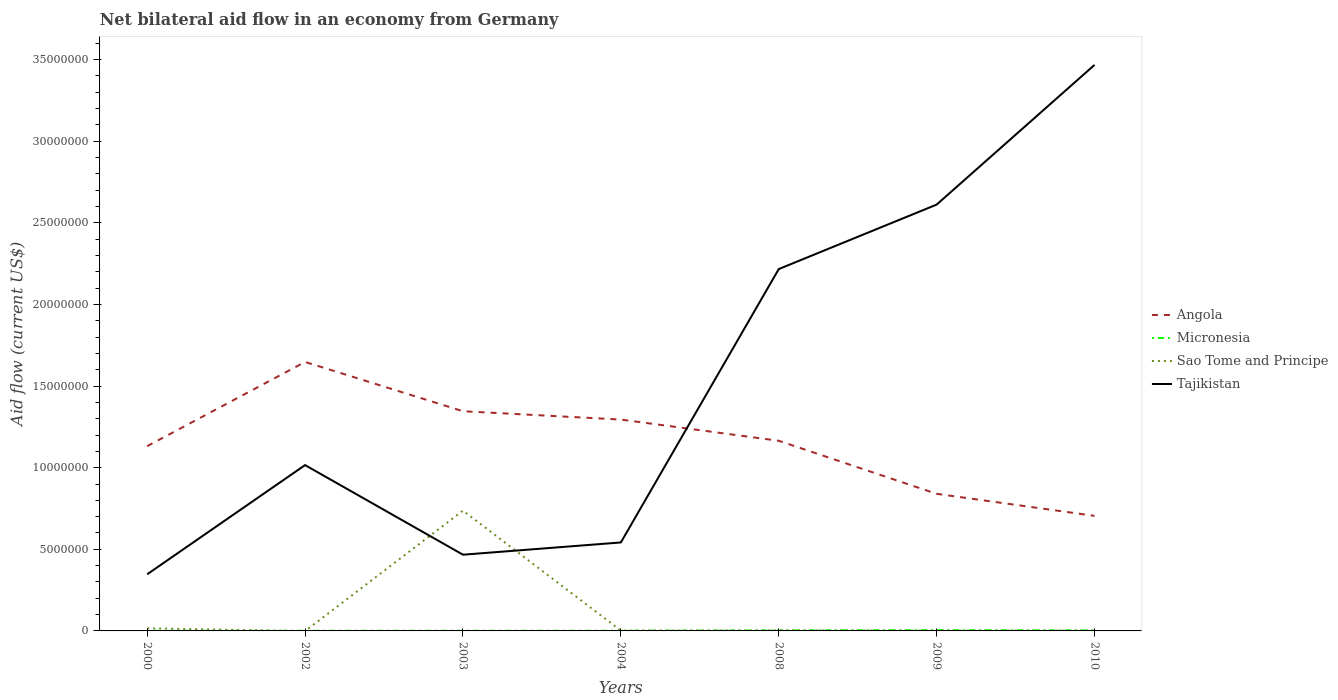Does the line corresponding to Angola intersect with the line corresponding to Tajikistan?
Your answer should be compact. Yes. What is the total net bilateral aid flow in Sao Tome and Principe in the graph?
Ensure brevity in your answer.  10000. What is the difference between the highest and the second highest net bilateral aid flow in Tajikistan?
Your response must be concise. 3.12e+07. What is the difference between two consecutive major ticks on the Y-axis?
Your answer should be very brief. 5.00e+06. Are the values on the major ticks of Y-axis written in scientific E-notation?
Your response must be concise. No. Does the graph contain grids?
Make the answer very short. No. Where does the legend appear in the graph?
Make the answer very short. Center right. What is the title of the graph?
Provide a succinct answer. Net bilateral aid flow in an economy from Germany. What is the Aid flow (current US$) in Angola in 2000?
Your response must be concise. 1.13e+07. What is the Aid flow (current US$) in Micronesia in 2000?
Give a very brief answer. 10000. What is the Aid flow (current US$) in Sao Tome and Principe in 2000?
Offer a terse response. 1.60e+05. What is the Aid flow (current US$) of Tajikistan in 2000?
Provide a short and direct response. 3.47e+06. What is the Aid flow (current US$) of Angola in 2002?
Ensure brevity in your answer.  1.65e+07. What is the Aid flow (current US$) in Micronesia in 2002?
Your answer should be very brief. 10000. What is the Aid flow (current US$) in Sao Tome and Principe in 2002?
Ensure brevity in your answer.  0. What is the Aid flow (current US$) in Tajikistan in 2002?
Your response must be concise. 1.02e+07. What is the Aid flow (current US$) of Angola in 2003?
Keep it short and to the point. 1.35e+07. What is the Aid flow (current US$) in Micronesia in 2003?
Your response must be concise. 10000. What is the Aid flow (current US$) of Sao Tome and Principe in 2003?
Give a very brief answer. 7.37e+06. What is the Aid flow (current US$) in Tajikistan in 2003?
Make the answer very short. 4.67e+06. What is the Aid flow (current US$) in Angola in 2004?
Your answer should be compact. 1.30e+07. What is the Aid flow (current US$) in Micronesia in 2004?
Your answer should be very brief. 10000. What is the Aid flow (current US$) of Tajikistan in 2004?
Your response must be concise. 5.42e+06. What is the Aid flow (current US$) of Angola in 2008?
Provide a succinct answer. 1.16e+07. What is the Aid flow (current US$) in Micronesia in 2008?
Provide a succinct answer. 3.00e+04. What is the Aid flow (current US$) of Sao Tome and Principe in 2008?
Give a very brief answer. 3.00e+04. What is the Aid flow (current US$) in Tajikistan in 2008?
Make the answer very short. 2.22e+07. What is the Aid flow (current US$) in Angola in 2009?
Ensure brevity in your answer.  8.40e+06. What is the Aid flow (current US$) in Tajikistan in 2009?
Your response must be concise. 2.61e+07. What is the Aid flow (current US$) in Angola in 2010?
Offer a very short reply. 7.05e+06. What is the Aid flow (current US$) in Micronesia in 2010?
Your answer should be very brief. 3.00e+04. What is the Aid flow (current US$) in Tajikistan in 2010?
Ensure brevity in your answer.  3.47e+07. Across all years, what is the maximum Aid flow (current US$) of Angola?
Offer a terse response. 1.65e+07. Across all years, what is the maximum Aid flow (current US$) in Micronesia?
Your answer should be very brief. 5.00e+04. Across all years, what is the maximum Aid flow (current US$) of Sao Tome and Principe?
Provide a short and direct response. 7.37e+06. Across all years, what is the maximum Aid flow (current US$) in Tajikistan?
Provide a succinct answer. 3.47e+07. Across all years, what is the minimum Aid flow (current US$) in Angola?
Provide a short and direct response. 7.05e+06. Across all years, what is the minimum Aid flow (current US$) in Sao Tome and Principe?
Keep it short and to the point. 0. Across all years, what is the minimum Aid flow (current US$) in Tajikistan?
Make the answer very short. 3.47e+06. What is the total Aid flow (current US$) in Angola in the graph?
Provide a succinct answer. 8.13e+07. What is the total Aid flow (current US$) in Micronesia in the graph?
Provide a succinct answer. 1.50e+05. What is the total Aid flow (current US$) in Sao Tome and Principe in the graph?
Ensure brevity in your answer.  7.61e+06. What is the total Aid flow (current US$) in Tajikistan in the graph?
Offer a very short reply. 1.07e+08. What is the difference between the Aid flow (current US$) in Angola in 2000 and that in 2002?
Your response must be concise. -5.16e+06. What is the difference between the Aid flow (current US$) of Micronesia in 2000 and that in 2002?
Provide a succinct answer. 0. What is the difference between the Aid flow (current US$) in Tajikistan in 2000 and that in 2002?
Provide a short and direct response. -6.69e+06. What is the difference between the Aid flow (current US$) in Angola in 2000 and that in 2003?
Make the answer very short. -2.14e+06. What is the difference between the Aid flow (current US$) of Sao Tome and Principe in 2000 and that in 2003?
Keep it short and to the point. -7.21e+06. What is the difference between the Aid flow (current US$) in Tajikistan in 2000 and that in 2003?
Ensure brevity in your answer.  -1.20e+06. What is the difference between the Aid flow (current US$) of Angola in 2000 and that in 2004?
Your response must be concise. -1.63e+06. What is the difference between the Aid flow (current US$) in Tajikistan in 2000 and that in 2004?
Provide a succinct answer. -1.95e+06. What is the difference between the Aid flow (current US$) in Angola in 2000 and that in 2008?
Your response must be concise. -3.30e+05. What is the difference between the Aid flow (current US$) of Tajikistan in 2000 and that in 2008?
Your answer should be compact. -1.87e+07. What is the difference between the Aid flow (current US$) in Angola in 2000 and that in 2009?
Offer a terse response. 2.92e+06. What is the difference between the Aid flow (current US$) of Micronesia in 2000 and that in 2009?
Provide a short and direct response. -4.00e+04. What is the difference between the Aid flow (current US$) of Tajikistan in 2000 and that in 2009?
Make the answer very short. -2.26e+07. What is the difference between the Aid flow (current US$) in Angola in 2000 and that in 2010?
Keep it short and to the point. 4.27e+06. What is the difference between the Aid flow (current US$) in Micronesia in 2000 and that in 2010?
Keep it short and to the point. -2.00e+04. What is the difference between the Aid flow (current US$) of Tajikistan in 2000 and that in 2010?
Offer a very short reply. -3.12e+07. What is the difference between the Aid flow (current US$) of Angola in 2002 and that in 2003?
Make the answer very short. 3.02e+06. What is the difference between the Aid flow (current US$) in Micronesia in 2002 and that in 2003?
Provide a succinct answer. 0. What is the difference between the Aid flow (current US$) of Tajikistan in 2002 and that in 2003?
Make the answer very short. 5.49e+06. What is the difference between the Aid flow (current US$) in Angola in 2002 and that in 2004?
Your answer should be compact. 3.53e+06. What is the difference between the Aid flow (current US$) in Micronesia in 2002 and that in 2004?
Provide a succinct answer. 0. What is the difference between the Aid flow (current US$) in Tajikistan in 2002 and that in 2004?
Offer a terse response. 4.74e+06. What is the difference between the Aid flow (current US$) of Angola in 2002 and that in 2008?
Your response must be concise. 4.83e+06. What is the difference between the Aid flow (current US$) of Micronesia in 2002 and that in 2008?
Make the answer very short. -2.00e+04. What is the difference between the Aid flow (current US$) of Tajikistan in 2002 and that in 2008?
Make the answer very short. -1.20e+07. What is the difference between the Aid flow (current US$) in Angola in 2002 and that in 2009?
Offer a very short reply. 8.08e+06. What is the difference between the Aid flow (current US$) in Micronesia in 2002 and that in 2009?
Provide a short and direct response. -4.00e+04. What is the difference between the Aid flow (current US$) of Tajikistan in 2002 and that in 2009?
Offer a very short reply. -1.60e+07. What is the difference between the Aid flow (current US$) in Angola in 2002 and that in 2010?
Provide a short and direct response. 9.43e+06. What is the difference between the Aid flow (current US$) in Tajikistan in 2002 and that in 2010?
Your answer should be compact. -2.45e+07. What is the difference between the Aid flow (current US$) of Angola in 2003 and that in 2004?
Offer a very short reply. 5.10e+05. What is the difference between the Aid flow (current US$) of Sao Tome and Principe in 2003 and that in 2004?
Offer a terse response. 7.35e+06. What is the difference between the Aid flow (current US$) of Tajikistan in 2003 and that in 2004?
Ensure brevity in your answer.  -7.50e+05. What is the difference between the Aid flow (current US$) in Angola in 2003 and that in 2008?
Make the answer very short. 1.81e+06. What is the difference between the Aid flow (current US$) of Sao Tome and Principe in 2003 and that in 2008?
Make the answer very short. 7.34e+06. What is the difference between the Aid flow (current US$) in Tajikistan in 2003 and that in 2008?
Your answer should be compact. -1.75e+07. What is the difference between the Aid flow (current US$) in Angola in 2003 and that in 2009?
Offer a very short reply. 5.06e+06. What is the difference between the Aid flow (current US$) of Micronesia in 2003 and that in 2009?
Provide a short and direct response. -4.00e+04. What is the difference between the Aid flow (current US$) of Sao Tome and Principe in 2003 and that in 2009?
Offer a terse response. 7.36e+06. What is the difference between the Aid flow (current US$) in Tajikistan in 2003 and that in 2009?
Offer a terse response. -2.14e+07. What is the difference between the Aid flow (current US$) in Angola in 2003 and that in 2010?
Your answer should be very brief. 6.41e+06. What is the difference between the Aid flow (current US$) in Micronesia in 2003 and that in 2010?
Give a very brief answer. -2.00e+04. What is the difference between the Aid flow (current US$) of Sao Tome and Principe in 2003 and that in 2010?
Make the answer very short. 7.35e+06. What is the difference between the Aid flow (current US$) of Tajikistan in 2003 and that in 2010?
Give a very brief answer. -3.00e+07. What is the difference between the Aid flow (current US$) in Angola in 2004 and that in 2008?
Your answer should be very brief. 1.30e+06. What is the difference between the Aid flow (current US$) in Tajikistan in 2004 and that in 2008?
Give a very brief answer. -1.68e+07. What is the difference between the Aid flow (current US$) in Angola in 2004 and that in 2009?
Ensure brevity in your answer.  4.55e+06. What is the difference between the Aid flow (current US$) in Tajikistan in 2004 and that in 2009?
Offer a terse response. -2.07e+07. What is the difference between the Aid flow (current US$) in Angola in 2004 and that in 2010?
Ensure brevity in your answer.  5.90e+06. What is the difference between the Aid flow (current US$) in Micronesia in 2004 and that in 2010?
Offer a terse response. -2.00e+04. What is the difference between the Aid flow (current US$) of Tajikistan in 2004 and that in 2010?
Make the answer very short. -2.93e+07. What is the difference between the Aid flow (current US$) of Angola in 2008 and that in 2009?
Your answer should be compact. 3.25e+06. What is the difference between the Aid flow (current US$) in Sao Tome and Principe in 2008 and that in 2009?
Your answer should be compact. 2.00e+04. What is the difference between the Aid flow (current US$) of Tajikistan in 2008 and that in 2009?
Provide a succinct answer. -3.95e+06. What is the difference between the Aid flow (current US$) in Angola in 2008 and that in 2010?
Your answer should be very brief. 4.60e+06. What is the difference between the Aid flow (current US$) of Micronesia in 2008 and that in 2010?
Your response must be concise. 0. What is the difference between the Aid flow (current US$) of Sao Tome and Principe in 2008 and that in 2010?
Provide a short and direct response. 10000. What is the difference between the Aid flow (current US$) of Tajikistan in 2008 and that in 2010?
Keep it short and to the point. -1.25e+07. What is the difference between the Aid flow (current US$) of Angola in 2009 and that in 2010?
Give a very brief answer. 1.35e+06. What is the difference between the Aid flow (current US$) in Tajikistan in 2009 and that in 2010?
Provide a succinct answer. -8.56e+06. What is the difference between the Aid flow (current US$) of Angola in 2000 and the Aid flow (current US$) of Micronesia in 2002?
Offer a very short reply. 1.13e+07. What is the difference between the Aid flow (current US$) in Angola in 2000 and the Aid flow (current US$) in Tajikistan in 2002?
Ensure brevity in your answer.  1.16e+06. What is the difference between the Aid flow (current US$) in Micronesia in 2000 and the Aid flow (current US$) in Tajikistan in 2002?
Provide a short and direct response. -1.02e+07. What is the difference between the Aid flow (current US$) of Sao Tome and Principe in 2000 and the Aid flow (current US$) of Tajikistan in 2002?
Make the answer very short. -1.00e+07. What is the difference between the Aid flow (current US$) in Angola in 2000 and the Aid flow (current US$) in Micronesia in 2003?
Keep it short and to the point. 1.13e+07. What is the difference between the Aid flow (current US$) in Angola in 2000 and the Aid flow (current US$) in Sao Tome and Principe in 2003?
Provide a short and direct response. 3.95e+06. What is the difference between the Aid flow (current US$) of Angola in 2000 and the Aid flow (current US$) of Tajikistan in 2003?
Your response must be concise. 6.65e+06. What is the difference between the Aid flow (current US$) of Micronesia in 2000 and the Aid flow (current US$) of Sao Tome and Principe in 2003?
Ensure brevity in your answer.  -7.36e+06. What is the difference between the Aid flow (current US$) of Micronesia in 2000 and the Aid flow (current US$) of Tajikistan in 2003?
Make the answer very short. -4.66e+06. What is the difference between the Aid flow (current US$) of Sao Tome and Principe in 2000 and the Aid flow (current US$) of Tajikistan in 2003?
Your answer should be compact. -4.51e+06. What is the difference between the Aid flow (current US$) of Angola in 2000 and the Aid flow (current US$) of Micronesia in 2004?
Give a very brief answer. 1.13e+07. What is the difference between the Aid flow (current US$) of Angola in 2000 and the Aid flow (current US$) of Sao Tome and Principe in 2004?
Your answer should be very brief. 1.13e+07. What is the difference between the Aid flow (current US$) in Angola in 2000 and the Aid flow (current US$) in Tajikistan in 2004?
Your response must be concise. 5.90e+06. What is the difference between the Aid flow (current US$) in Micronesia in 2000 and the Aid flow (current US$) in Tajikistan in 2004?
Your answer should be very brief. -5.41e+06. What is the difference between the Aid flow (current US$) of Sao Tome and Principe in 2000 and the Aid flow (current US$) of Tajikistan in 2004?
Keep it short and to the point. -5.26e+06. What is the difference between the Aid flow (current US$) of Angola in 2000 and the Aid flow (current US$) of Micronesia in 2008?
Ensure brevity in your answer.  1.13e+07. What is the difference between the Aid flow (current US$) in Angola in 2000 and the Aid flow (current US$) in Sao Tome and Principe in 2008?
Ensure brevity in your answer.  1.13e+07. What is the difference between the Aid flow (current US$) of Angola in 2000 and the Aid flow (current US$) of Tajikistan in 2008?
Your answer should be compact. -1.08e+07. What is the difference between the Aid flow (current US$) in Micronesia in 2000 and the Aid flow (current US$) in Tajikistan in 2008?
Make the answer very short. -2.22e+07. What is the difference between the Aid flow (current US$) of Sao Tome and Principe in 2000 and the Aid flow (current US$) of Tajikistan in 2008?
Your answer should be very brief. -2.20e+07. What is the difference between the Aid flow (current US$) of Angola in 2000 and the Aid flow (current US$) of Micronesia in 2009?
Make the answer very short. 1.13e+07. What is the difference between the Aid flow (current US$) in Angola in 2000 and the Aid flow (current US$) in Sao Tome and Principe in 2009?
Offer a very short reply. 1.13e+07. What is the difference between the Aid flow (current US$) of Angola in 2000 and the Aid flow (current US$) of Tajikistan in 2009?
Your answer should be very brief. -1.48e+07. What is the difference between the Aid flow (current US$) in Micronesia in 2000 and the Aid flow (current US$) in Sao Tome and Principe in 2009?
Your answer should be compact. 0. What is the difference between the Aid flow (current US$) in Micronesia in 2000 and the Aid flow (current US$) in Tajikistan in 2009?
Your answer should be very brief. -2.61e+07. What is the difference between the Aid flow (current US$) in Sao Tome and Principe in 2000 and the Aid flow (current US$) in Tajikistan in 2009?
Ensure brevity in your answer.  -2.60e+07. What is the difference between the Aid flow (current US$) of Angola in 2000 and the Aid flow (current US$) of Micronesia in 2010?
Your answer should be compact. 1.13e+07. What is the difference between the Aid flow (current US$) of Angola in 2000 and the Aid flow (current US$) of Sao Tome and Principe in 2010?
Give a very brief answer. 1.13e+07. What is the difference between the Aid flow (current US$) of Angola in 2000 and the Aid flow (current US$) of Tajikistan in 2010?
Give a very brief answer. -2.34e+07. What is the difference between the Aid flow (current US$) of Micronesia in 2000 and the Aid flow (current US$) of Tajikistan in 2010?
Your response must be concise. -3.47e+07. What is the difference between the Aid flow (current US$) in Sao Tome and Principe in 2000 and the Aid flow (current US$) in Tajikistan in 2010?
Your answer should be very brief. -3.45e+07. What is the difference between the Aid flow (current US$) in Angola in 2002 and the Aid flow (current US$) in Micronesia in 2003?
Provide a succinct answer. 1.65e+07. What is the difference between the Aid flow (current US$) of Angola in 2002 and the Aid flow (current US$) of Sao Tome and Principe in 2003?
Give a very brief answer. 9.11e+06. What is the difference between the Aid flow (current US$) in Angola in 2002 and the Aid flow (current US$) in Tajikistan in 2003?
Keep it short and to the point. 1.18e+07. What is the difference between the Aid flow (current US$) of Micronesia in 2002 and the Aid flow (current US$) of Sao Tome and Principe in 2003?
Keep it short and to the point. -7.36e+06. What is the difference between the Aid flow (current US$) of Micronesia in 2002 and the Aid flow (current US$) of Tajikistan in 2003?
Your response must be concise. -4.66e+06. What is the difference between the Aid flow (current US$) of Angola in 2002 and the Aid flow (current US$) of Micronesia in 2004?
Offer a terse response. 1.65e+07. What is the difference between the Aid flow (current US$) in Angola in 2002 and the Aid flow (current US$) in Sao Tome and Principe in 2004?
Your response must be concise. 1.65e+07. What is the difference between the Aid flow (current US$) of Angola in 2002 and the Aid flow (current US$) of Tajikistan in 2004?
Offer a very short reply. 1.11e+07. What is the difference between the Aid flow (current US$) in Micronesia in 2002 and the Aid flow (current US$) in Tajikistan in 2004?
Your answer should be compact. -5.41e+06. What is the difference between the Aid flow (current US$) of Angola in 2002 and the Aid flow (current US$) of Micronesia in 2008?
Ensure brevity in your answer.  1.64e+07. What is the difference between the Aid flow (current US$) in Angola in 2002 and the Aid flow (current US$) in Sao Tome and Principe in 2008?
Provide a short and direct response. 1.64e+07. What is the difference between the Aid flow (current US$) of Angola in 2002 and the Aid flow (current US$) of Tajikistan in 2008?
Provide a succinct answer. -5.69e+06. What is the difference between the Aid flow (current US$) of Micronesia in 2002 and the Aid flow (current US$) of Sao Tome and Principe in 2008?
Keep it short and to the point. -2.00e+04. What is the difference between the Aid flow (current US$) of Micronesia in 2002 and the Aid flow (current US$) of Tajikistan in 2008?
Ensure brevity in your answer.  -2.22e+07. What is the difference between the Aid flow (current US$) of Angola in 2002 and the Aid flow (current US$) of Micronesia in 2009?
Offer a terse response. 1.64e+07. What is the difference between the Aid flow (current US$) in Angola in 2002 and the Aid flow (current US$) in Sao Tome and Principe in 2009?
Ensure brevity in your answer.  1.65e+07. What is the difference between the Aid flow (current US$) of Angola in 2002 and the Aid flow (current US$) of Tajikistan in 2009?
Your answer should be very brief. -9.64e+06. What is the difference between the Aid flow (current US$) in Micronesia in 2002 and the Aid flow (current US$) in Tajikistan in 2009?
Keep it short and to the point. -2.61e+07. What is the difference between the Aid flow (current US$) in Angola in 2002 and the Aid flow (current US$) in Micronesia in 2010?
Make the answer very short. 1.64e+07. What is the difference between the Aid flow (current US$) of Angola in 2002 and the Aid flow (current US$) of Sao Tome and Principe in 2010?
Make the answer very short. 1.65e+07. What is the difference between the Aid flow (current US$) of Angola in 2002 and the Aid flow (current US$) of Tajikistan in 2010?
Give a very brief answer. -1.82e+07. What is the difference between the Aid flow (current US$) of Micronesia in 2002 and the Aid flow (current US$) of Sao Tome and Principe in 2010?
Keep it short and to the point. -10000. What is the difference between the Aid flow (current US$) in Micronesia in 2002 and the Aid flow (current US$) in Tajikistan in 2010?
Give a very brief answer. -3.47e+07. What is the difference between the Aid flow (current US$) in Angola in 2003 and the Aid flow (current US$) in Micronesia in 2004?
Give a very brief answer. 1.34e+07. What is the difference between the Aid flow (current US$) in Angola in 2003 and the Aid flow (current US$) in Sao Tome and Principe in 2004?
Give a very brief answer. 1.34e+07. What is the difference between the Aid flow (current US$) in Angola in 2003 and the Aid flow (current US$) in Tajikistan in 2004?
Provide a succinct answer. 8.04e+06. What is the difference between the Aid flow (current US$) of Micronesia in 2003 and the Aid flow (current US$) of Sao Tome and Principe in 2004?
Provide a succinct answer. -10000. What is the difference between the Aid flow (current US$) in Micronesia in 2003 and the Aid flow (current US$) in Tajikistan in 2004?
Your answer should be very brief. -5.41e+06. What is the difference between the Aid flow (current US$) of Sao Tome and Principe in 2003 and the Aid flow (current US$) of Tajikistan in 2004?
Offer a terse response. 1.95e+06. What is the difference between the Aid flow (current US$) in Angola in 2003 and the Aid flow (current US$) in Micronesia in 2008?
Provide a succinct answer. 1.34e+07. What is the difference between the Aid flow (current US$) of Angola in 2003 and the Aid flow (current US$) of Sao Tome and Principe in 2008?
Provide a succinct answer. 1.34e+07. What is the difference between the Aid flow (current US$) in Angola in 2003 and the Aid flow (current US$) in Tajikistan in 2008?
Your answer should be compact. -8.71e+06. What is the difference between the Aid flow (current US$) of Micronesia in 2003 and the Aid flow (current US$) of Tajikistan in 2008?
Your response must be concise. -2.22e+07. What is the difference between the Aid flow (current US$) in Sao Tome and Principe in 2003 and the Aid flow (current US$) in Tajikistan in 2008?
Give a very brief answer. -1.48e+07. What is the difference between the Aid flow (current US$) in Angola in 2003 and the Aid flow (current US$) in Micronesia in 2009?
Give a very brief answer. 1.34e+07. What is the difference between the Aid flow (current US$) in Angola in 2003 and the Aid flow (current US$) in Sao Tome and Principe in 2009?
Your answer should be very brief. 1.34e+07. What is the difference between the Aid flow (current US$) of Angola in 2003 and the Aid flow (current US$) of Tajikistan in 2009?
Provide a succinct answer. -1.27e+07. What is the difference between the Aid flow (current US$) in Micronesia in 2003 and the Aid flow (current US$) in Tajikistan in 2009?
Your answer should be very brief. -2.61e+07. What is the difference between the Aid flow (current US$) in Sao Tome and Principe in 2003 and the Aid flow (current US$) in Tajikistan in 2009?
Make the answer very short. -1.88e+07. What is the difference between the Aid flow (current US$) in Angola in 2003 and the Aid flow (current US$) in Micronesia in 2010?
Your answer should be compact. 1.34e+07. What is the difference between the Aid flow (current US$) in Angola in 2003 and the Aid flow (current US$) in Sao Tome and Principe in 2010?
Your answer should be very brief. 1.34e+07. What is the difference between the Aid flow (current US$) in Angola in 2003 and the Aid flow (current US$) in Tajikistan in 2010?
Make the answer very short. -2.12e+07. What is the difference between the Aid flow (current US$) of Micronesia in 2003 and the Aid flow (current US$) of Sao Tome and Principe in 2010?
Make the answer very short. -10000. What is the difference between the Aid flow (current US$) of Micronesia in 2003 and the Aid flow (current US$) of Tajikistan in 2010?
Your answer should be very brief. -3.47e+07. What is the difference between the Aid flow (current US$) in Sao Tome and Principe in 2003 and the Aid flow (current US$) in Tajikistan in 2010?
Offer a terse response. -2.73e+07. What is the difference between the Aid flow (current US$) in Angola in 2004 and the Aid flow (current US$) in Micronesia in 2008?
Keep it short and to the point. 1.29e+07. What is the difference between the Aid flow (current US$) in Angola in 2004 and the Aid flow (current US$) in Sao Tome and Principe in 2008?
Your answer should be very brief. 1.29e+07. What is the difference between the Aid flow (current US$) of Angola in 2004 and the Aid flow (current US$) of Tajikistan in 2008?
Offer a terse response. -9.22e+06. What is the difference between the Aid flow (current US$) of Micronesia in 2004 and the Aid flow (current US$) of Sao Tome and Principe in 2008?
Offer a very short reply. -2.00e+04. What is the difference between the Aid flow (current US$) in Micronesia in 2004 and the Aid flow (current US$) in Tajikistan in 2008?
Your answer should be very brief. -2.22e+07. What is the difference between the Aid flow (current US$) in Sao Tome and Principe in 2004 and the Aid flow (current US$) in Tajikistan in 2008?
Give a very brief answer. -2.22e+07. What is the difference between the Aid flow (current US$) of Angola in 2004 and the Aid flow (current US$) of Micronesia in 2009?
Offer a very short reply. 1.29e+07. What is the difference between the Aid flow (current US$) in Angola in 2004 and the Aid flow (current US$) in Sao Tome and Principe in 2009?
Provide a succinct answer. 1.29e+07. What is the difference between the Aid flow (current US$) of Angola in 2004 and the Aid flow (current US$) of Tajikistan in 2009?
Offer a very short reply. -1.32e+07. What is the difference between the Aid flow (current US$) in Micronesia in 2004 and the Aid flow (current US$) in Tajikistan in 2009?
Give a very brief answer. -2.61e+07. What is the difference between the Aid flow (current US$) of Sao Tome and Principe in 2004 and the Aid flow (current US$) of Tajikistan in 2009?
Offer a terse response. -2.61e+07. What is the difference between the Aid flow (current US$) in Angola in 2004 and the Aid flow (current US$) in Micronesia in 2010?
Give a very brief answer. 1.29e+07. What is the difference between the Aid flow (current US$) in Angola in 2004 and the Aid flow (current US$) in Sao Tome and Principe in 2010?
Provide a short and direct response. 1.29e+07. What is the difference between the Aid flow (current US$) in Angola in 2004 and the Aid flow (current US$) in Tajikistan in 2010?
Provide a short and direct response. -2.17e+07. What is the difference between the Aid flow (current US$) of Micronesia in 2004 and the Aid flow (current US$) of Tajikistan in 2010?
Offer a terse response. -3.47e+07. What is the difference between the Aid flow (current US$) in Sao Tome and Principe in 2004 and the Aid flow (current US$) in Tajikistan in 2010?
Ensure brevity in your answer.  -3.47e+07. What is the difference between the Aid flow (current US$) in Angola in 2008 and the Aid flow (current US$) in Micronesia in 2009?
Your answer should be compact. 1.16e+07. What is the difference between the Aid flow (current US$) in Angola in 2008 and the Aid flow (current US$) in Sao Tome and Principe in 2009?
Offer a very short reply. 1.16e+07. What is the difference between the Aid flow (current US$) in Angola in 2008 and the Aid flow (current US$) in Tajikistan in 2009?
Your answer should be very brief. -1.45e+07. What is the difference between the Aid flow (current US$) in Micronesia in 2008 and the Aid flow (current US$) in Sao Tome and Principe in 2009?
Your answer should be very brief. 2.00e+04. What is the difference between the Aid flow (current US$) of Micronesia in 2008 and the Aid flow (current US$) of Tajikistan in 2009?
Keep it short and to the point. -2.61e+07. What is the difference between the Aid flow (current US$) in Sao Tome and Principe in 2008 and the Aid flow (current US$) in Tajikistan in 2009?
Make the answer very short. -2.61e+07. What is the difference between the Aid flow (current US$) in Angola in 2008 and the Aid flow (current US$) in Micronesia in 2010?
Offer a terse response. 1.16e+07. What is the difference between the Aid flow (current US$) of Angola in 2008 and the Aid flow (current US$) of Sao Tome and Principe in 2010?
Your answer should be very brief. 1.16e+07. What is the difference between the Aid flow (current US$) of Angola in 2008 and the Aid flow (current US$) of Tajikistan in 2010?
Provide a short and direct response. -2.30e+07. What is the difference between the Aid flow (current US$) of Micronesia in 2008 and the Aid flow (current US$) of Tajikistan in 2010?
Keep it short and to the point. -3.46e+07. What is the difference between the Aid flow (current US$) of Sao Tome and Principe in 2008 and the Aid flow (current US$) of Tajikistan in 2010?
Offer a very short reply. -3.46e+07. What is the difference between the Aid flow (current US$) in Angola in 2009 and the Aid flow (current US$) in Micronesia in 2010?
Your answer should be compact. 8.37e+06. What is the difference between the Aid flow (current US$) in Angola in 2009 and the Aid flow (current US$) in Sao Tome and Principe in 2010?
Ensure brevity in your answer.  8.38e+06. What is the difference between the Aid flow (current US$) of Angola in 2009 and the Aid flow (current US$) of Tajikistan in 2010?
Offer a very short reply. -2.63e+07. What is the difference between the Aid flow (current US$) in Micronesia in 2009 and the Aid flow (current US$) in Sao Tome and Principe in 2010?
Offer a terse response. 3.00e+04. What is the difference between the Aid flow (current US$) in Micronesia in 2009 and the Aid flow (current US$) in Tajikistan in 2010?
Your answer should be compact. -3.46e+07. What is the difference between the Aid flow (current US$) of Sao Tome and Principe in 2009 and the Aid flow (current US$) of Tajikistan in 2010?
Offer a very short reply. -3.47e+07. What is the average Aid flow (current US$) in Angola per year?
Your response must be concise. 1.16e+07. What is the average Aid flow (current US$) of Micronesia per year?
Give a very brief answer. 2.14e+04. What is the average Aid flow (current US$) of Sao Tome and Principe per year?
Your answer should be very brief. 1.09e+06. What is the average Aid flow (current US$) in Tajikistan per year?
Your response must be concise. 1.52e+07. In the year 2000, what is the difference between the Aid flow (current US$) in Angola and Aid flow (current US$) in Micronesia?
Offer a very short reply. 1.13e+07. In the year 2000, what is the difference between the Aid flow (current US$) in Angola and Aid flow (current US$) in Sao Tome and Principe?
Provide a succinct answer. 1.12e+07. In the year 2000, what is the difference between the Aid flow (current US$) of Angola and Aid flow (current US$) of Tajikistan?
Your response must be concise. 7.85e+06. In the year 2000, what is the difference between the Aid flow (current US$) in Micronesia and Aid flow (current US$) in Sao Tome and Principe?
Make the answer very short. -1.50e+05. In the year 2000, what is the difference between the Aid flow (current US$) in Micronesia and Aid flow (current US$) in Tajikistan?
Ensure brevity in your answer.  -3.46e+06. In the year 2000, what is the difference between the Aid flow (current US$) in Sao Tome and Principe and Aid flow (current US$) in Tajikistan?
Your response must be concise. -3.31e+06. In the year 2002, what is the difference between the Aid flow (current US$) of Angola and Aid flow (current US$) of Micronesia?
Give a very brief answer. 1.65e+07. In the year 2002, what is the difference between the Aid flow (current US$) of Angola and Aid flow (current US$) of Tajikistan?
Your answer should be very brief. 6.32e+06. In the year 2002, what is the difference between the Aid flow (current US$) of Micronesia and Aid flow (current US$) of Tajikistan?
Make the answer very short. -1.02e+07. In the year 2003, what is the difference between the Aid flow (current US$) in Angola and Aid flow (current US$) in Micronesia?
Give a very brief answer. 1.34e+07. In the year 2003, what is the difference between the Aid flow (current US$) of Angola and Aid flow (current US$) of Sao Tome and Principe?
Offer a terse response. 6.09e+06. In the year 2003, what is the difference between the Aid flow (current US$) of Angola and Aid flow (current US$) of Tajikistan?
Your response must be concise. 8.79e+06. In the year 2003, what is the difference between the Aid flow (current US$) in Micronesia and Aid flow (current US$) in Sao Tome and Principe?
Provide a short and direct response. -7.36e+06. In the year 2003, what is the difference between the Aid flow (current US$) in Micronesia and Aid flow (current US$) in Tajikistan?
Your answer should be very brief. -4.66e+06. In the year 2003, what is the difference between the Aid flow (current US$) in Sao Tome and Principe and Aid flow (current US$) in Tajikistan?
Give a very brief answer. 2.70e+06. In the year 2004, what is the difference between the Aid flow (current US$) of Angola and Aid flow (current US$) of Micronesia?
Make the answer very short. 1.29e+07. In the year 2004, what is the difference between the Aid flow (current US$) in Angola and Aid flow (current US$) in Sao Tome and Principe?
Keep it short and to the point. 1.29e+07. In the year 2004, what is the difference between the Aid flow (current US$) of Angola and Aid flow (current US$) of Tajikistan?
Ensure brevity in your answer.  7.53e+06. In the year 2004, what is the difference between the Aid flow (current US$) in Micronesia and Aid flow (current US$) in Sao Tome and Principe?
Ensure brevity in your answer.  -10000. In the year 2004, what is the difference between the Aid flow (current US$) in Micronesia and Aid flow (current US$) in Tajikistan?
Give a very brief answer. -5.41e+06. In the year 2004, what is the difference between the Aid flow (current US$) in Sao Tome and Principe and Aid flow (current US$) in Tajikistan?
Provide a succinct answer. -5.40e+06. In the year 2008, what is the difference between the Aid flow (current US$) in Angola and Aid flow (current US$) in Micronesia?
Keep it short and to the point. 1.16e+07. In the year 2008, what is the difference between the Aid flow (current US$) of Angola and Aid flow (current US$) of Sao Tome and Principe?
Your response must be concise. 1.16e+07. In the year 2008, what is the difference between the Aid flow (current US$) of Angola and Aid flow (current US$) of Tajikistan?
Ensure brevity in your answer.  -1.05e+07. In the year 2008, what is the difference between the Aid flow (current US$) of Micronesia and Aid flow (current US$) of Tajikistan?
Offer a terse response. -2.21e+07. In the year 2008, what is the difference between the Aid flow (current US$) of Sao Tome and Principe and Aid flow (current US$) of Tajikistan?
Your response must be concise. -2.21e+07. In the year 2009, what is the difference between the Aid flow (current US$) in Angola and Aid flow (current US$) in Micronesia?
Your answer should be very brief. 8.35e+06. In the year 2009, what is the difference between the Aid flow (current US$) in Angola and Aid flow (current US$) in Sao Tome and Principe?
Offer a terse response. 8.39e+06. In the year 2009, what is the difference between the Aid flow (current US$) of Angola and Aid flow (current US$) of Tajikistan?
Your response must be concise. -1.77e+07. In the year 2009, what is the difference between the Aid flow (current US$) of Micronesia and Aid flow (current US$) of Sao Tome and Principe?
Provide a short and direct response. 4.00e+04. In the year 2009, what is the difference between the Aid flow (current US$) of Micronesia and Aid flow (current US$) of Tajikistan?
Offer a terse response. -2.61e+07. In the year 2009, what is the difference between the Aid flow (current US$) of Sao Tome and Principe and Aid flow (current US$) of Tajikistan?
Offer a very short reply. -2.61e+07. In the year 2010, what is the difference between the Aid flow (current US$) in Angola and Aid flow (current US$) in Micronesia?
Your answer should be compact. 7.02e+06. In the year 2010, what is the difference between the Aid flow (current US$) in Angola and Aid flow (current US$) in Sao Tome and Principe?
Your answer should be compact. 7.03e+06. In the year 2010, what is the difference between the Aid flow (current US$) in Angola and Aid flow (current US$) in Tajikistan?
Provide a short and direct response. -2.76e+07. In the year 2010, what is the difference between the Aid flow (current US$) in Micronesia and Aid flow (current US$) in Sao Tome and Principe?
Keep it short and to the point. 10000. In the year 2010, what is the difference between the Aid flow (current US$) of Micronesia and Aid flow (current US$) of Tajikistan?
Offer a very short reply. -3.46e+07. In the year 2010, what is the difference between the Aid flow (current US$) in Sao Tome and Principe and Aid flow (current US$) in Tajikistan?
Offer a very short reply. -3.47e+07. What is the ratio of the Aid flow (current US$) of Angola in 2000 to that in 2002?
Offer a terse response. 0.69. What is the ratio of the Aid flow (current US$) of Tajikistan in 2000 to that in 2002?
Ensure brevity in your answer.  0.34. What is the ratio of the Aid flow (current US$) of Angola in 2000 to that in 2003?
Offer a terse response. 0.84. What is the ratio of the Aid flow (current US$) in Sao Tome and Principe in 2000 to that in 2003?
Your answer should be very brief. 0.02. What is the ratio of the Aid flow (current US$) in Tajikistan in 2000 to that in 2003?
Keep it short and to the point. 0.74. What is the ratio of the Aid flow (current US$) of Angola in 2000 to that in 2004?
Offer a terse response. 0.87. What is the ratio of the Aid flow (current US$) in Micronesia in 2000 to that in 2004?
Your response must be concise. 1. What is the ratio of the Aid flow (current US$) of Sao Tome and Principe in 2000 to that in 2004?
Your answer should be very brief. 8. What is the ratio of the Aid flow (current US$) of Tajikistan in 2000 to that in 2004?
Your answer should be very brief. 0.64. What is the ratio of the Aid flow (current US$) in Angola in 2000 to that in 2008?
Provide a short and direct response. 0.97. What is the ratio of the Aid flow (current US$) of Sao Tome and Principe in 2000 to that in 2008?
Give a very brief answer. 5.33. What is the ratio of the Aid flow (current US$) in Tajikistan in 2000 to that in 2008?
Ensure brevity in your answer.  0.16. What is the ratio of the Aid flow (current US$) in Angola in 2000 to that in 2009?
Your response must be concise. 1.35. What is the ratio of the Aid flow (current US$) of Micronesia in 2000 to that in 2009?
Offer a very short reply. 0.2. What is the ratio of the Aid flow (current US$) in Sao Tome and Principe in 2000 to that in 2009?
Offer a very short reply. 16. What is the ratio of the Aid flow (current US$) in Tajikistan in 2000 to that in 2009?
Your answer should be very brief. 0.13. What is the ratio of the Aid flow (current US$) in Angola in 2000 to that in 2010?
Keep it short and to the point. 1.61. What is the ratio of the Aid flow (current US$) of Micronesia in 2000 to that in 2010?
Offer a terse response. 0.33. What is the ratio of the Aid flow (current US$) in Tajikistan in 2000 to that in 2010?
Keep it short and to the point. 0.1. What is the ratio of the Aid flow (current US$) in Angola in 2002 to that in 2003?
Offer a terse response. 1.22. What is the ratio of the Aid flow (current US$) of Micronesia in 2002 to that in 2003?
Your response must be concise. 1. What is the ratio of the Aid flow (current US$) in Tajikistan in 2002 to that in 2003?
Ensure brevity in your answer.  2.18. What is the ratio of the Aid flow (current US$) of Angola in 2002 to that in 2004?
Your answer should be compact. 1.27. What is the ratio of the Aid flow (current US$) of Micronesia in 2002 to that in 2004?
Your answer should be compact. 1. What is the ratio of the Aid flow (current US$) of Tajikistan in 2002 to that in 2004?
Your response must be concise. 1.87. What is the ratio of the Aid flow (current US$) of Angola in 2002 to that in 2008?
Give a very brief answer. 1.41. What is the ratio of the Aid flow (current US$) of Micronesia in 2002 to that in 2008?
Provide a short and direct response. 0.33. What is the ratio of the Aid flow (current US$) of Tajikistan in 2002 to that in 2008?
Provide a short and direct response. 0.46. What is the ratio of the Aid flow (current US$) in Angola in 2002 to that in 2009?
Provide a short and direct response. 1.96. What is the ratio of the Aid flow (current US$) in Tajikistan in 2002 to that in 2009?
Make the answer very short. 0.39. What is the ratio of the Aid flow (current US$) of Angola in 2002 to that in 2010?
Keep it short and to the point. 2.34. What is the ratio of the Aid flow (current US$) of Tajikistan in 2002 to that in 2010?
Provide a short and direct response. 0.29. What is the ratio of the Aid flow (current US$) in Angola in 2003 to that in 2004?
Ensure brevity in your answer.  1.04. What is the ratio of the Aid flow (current US$) in Sao Tome and Principe in 2003 to that in 2004?
Your answer should be compact. 368.5. What is the ratio of the Aid flow (current US$) in Tajikistan in 2003 to that in 2004?
Keep it short and to the point. 0.86. What is the ratio of the Aid flow (current US$) of Angola in 2003 to that in 2008?
Provide a short and direct response. 1.16. What is the ratio of the Aid flow (current US$) in Sao Tome and Principe in 2003 to that in 2008?
Make the answer very short. 245.67. What is the ratio of the Aid flow (current US$) in Tajikistan in 2003 to that in 2008?
Give a very brief answer. 0.21. What is the ratio of the Aid flow (current US$) in Angola in 2003 to that in 2009?
Your response must be concise. 1.6. What is the ratio of the Aid flow (current US$) of Sao Tome and Principe in 2003 to that in 2009?
Provide a short and direct response. 737. What is the ratio of the Aid flow (current US$) in Tajikistan in 2003 to that in 2009?
Your response must be concise. 0.18. What is the ratio of the Aid flow (current US$) of Angola in 2003 to that in 2010?
Provide a short and direct response. 1.91. What is the ratio of the Aid flow (current US$) in Micronesia in 2003 to that in 2010?
Your response must be concise. 0.33. What is the ratio of the Aid flow (current US$) in Sao Tome and Principe in 2003 to that in 2010?
Your response must be concise. 368.5. What is the ratio of the Aid flow (current US$) in Tajikistan in 2003 to that in 2010?
Provide a short and direct response. 0.13. What is the ratio of the Aid flow (current US$) of Angola in 2004 to that in 2008?
Your answer should be very brief. 1.11. What is the ratio of the Aid flow (current US$) in Sao Tome and Principe in 2004 to that in 2008?
Offer a very short reply. 0.67. What is the ratio of the Aid flow (current US$) in Tajikistan in 2004 to that in 2008?
Provide a short and direct response. 0.24. What is the ratio of the Aid flow (current US$) of Angola in 2004 to that in 2009?
Offer a terse response. 1.54. What is the ratio of the Aid flow (current US$) in Sao Tome and Principe in 2004 to that in 2009?
Ensure brevity in your answer.  2. What is the ratio of the Aid flow (current US$) in Tajikistan in 2004 to that in 2009?
Make the answer very short. 0.21. What is the ratio of the Aid flow (current US$) of Angola in 2004 to that in 2010?
Provide a succinct answer. 1.84. What is the ratio of the Aid flow (current US$) in Micronesia in 2004 to that in 2010?
Provide a short and direct response. 0.33. What is the ratio of the Aid flow (current US$) in Sao Tome and Principe in 2004 to that in 2010?
Give a very brief answer. 1. What is the ratio of the Aid flow (current US$) of Tajikistan in 2004 to that in 2010?
Your answer should be compact. 0.16. What is the ratio of the Aid flow (current US$) of Angola in 2008 to that in 2009?
Ensure brevity in your answer.  1.39. What is the ratio of the Aid flow (current US$) in Micronesia in 2008 to that in 2009?
Offer a very short reply. 0.6. What is the ratio of the Aid flow (current US$) in Tajikistan in 2008 to that in 2009?
Provide a succinct answer. 0.85. What is the ratio of the Aid flow (current US$) in Angola in 2008 to that in 2010?
Keep it short and to the point. 1.65. What is the ratio of the Aid flow (current US$) of Sao Tome and Principe in 2008 to that in 2010?
Give a very brief answer. 1.5. What is the ratio of the Aid flow (current US$) in Tajikistan in 2008 to that in 2010?
Provide a short and direct response. 0.64. What is the ratio of the Aid flow (current US$) of Angola in 2009 to that in 2010?
Provide a short and direct response. 1.19. What is the ratio of the Aid flow (current US$) of Micronesia in 2009 to that in 2010?
Make the answer very short. 1.67. What is the ratio of the Aid flow (current US$) of Sao Tome and Principe in 2009 to that in 2010?
Give a very brief answer. 0.5. What is the ratio of the Aid flow (current US$) of Tajikistan in 2009 to that in 2010?
Your answer should be compact. 0.75. What is the difference between the highest and the second highest Aid flow (current US$) in Angola?
Your response must be concise. 3.02e+06. What is the difference between the highest and the second highest Aid flow (current US$) of Sao Tome and Principe?
Offer a terse response. 7.21e+06. What is the difference between the highest and the second highest Aid flow (current US$) of Tajikistan?
Ensure brevity in your answer.  8.56e+06. What is the difference between the highest and the lowest Aid flow (current US$) of Angola?
Your answer should be very brief. 9.43e+06. What is the difference between the highest and the lowest Aid flow (current US$) in Micronesia?
Keep it short and to the point. 4.00e+04. What is the difference between the highest and the lowest Aid flow (current US$) of Sao Tome and Principe?
Provide a succinct answer. 7.37e+06. What is the difference between the highest and the lowest Aid flow (current US$) in Tajikistan?
Make the answer very short. 3.12e+07. 